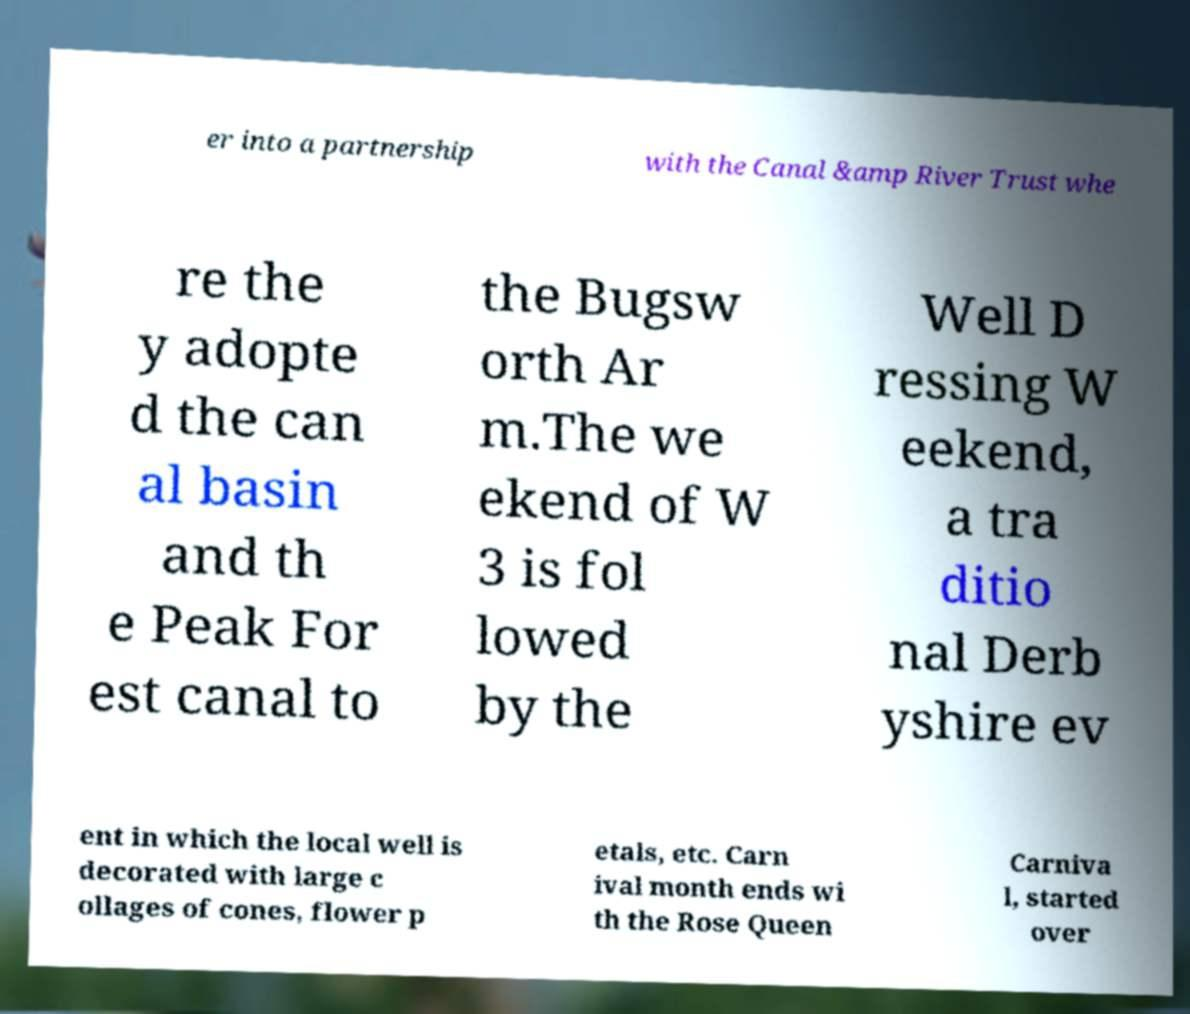I need the written content from this picture converted into text. Can you do that? er into a partnership with the Canal &amp River Trust whe re the y adopte d the can al basin and th e Peak For est canal to the Bugsw orth Ar m.The we ekend of W 3 is fol lowed by the Well D ressing W eekend, a tra ditio nal Derb yshire ev ent in which the local well is decorated with large c ollages of cones, flower p etals, etc. Carn ival month ends wi th the Rose Queen Carniva l, started over 